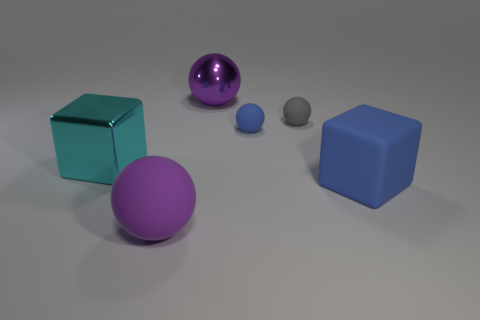What number of metallic things are either tiny gray things or big objects?
Offer a terse response. 2. Is there any other thing that is the same material as the large cyan cube?
Give a very brief answer. Yes. There is a shiny thing that is in front of the shiny thing that is on the right side of the purple thing in front of the purple metallic thing; what is its size?
Ensure brevity in your answer.  Large. There is a object that is both right of the tiny blue thing and to the left of the large blue rubber block; what size is it?
Offer a very short reply. Small. There is a matte ball in front of the metallic cube; is its color the same as the large shiny thing that is to the right of the big cyan cube?
Your answer should be compact. Yes. There is a purple metallic thing; how many spheres are on the left side of it?
Make the answer very short. 1. Is there a thing that is on the right side of the large metallic object that is on the right side of the big purple thing that is in front of the large blue cube?
Your answer should be compact. Yes. What number of blue rubber balls are the same size as the rubber block?
Offer a very short reply. 0. What is the material of the cube to the right of the sphere in front of the large cyan metallic block?
Your response must be concise. Rubber. What shape is the purple thing in front of the thing that is on the left side of the purple sphere that is in front of the large blue object?
Ensure brevity in your answer.  Sphere. 